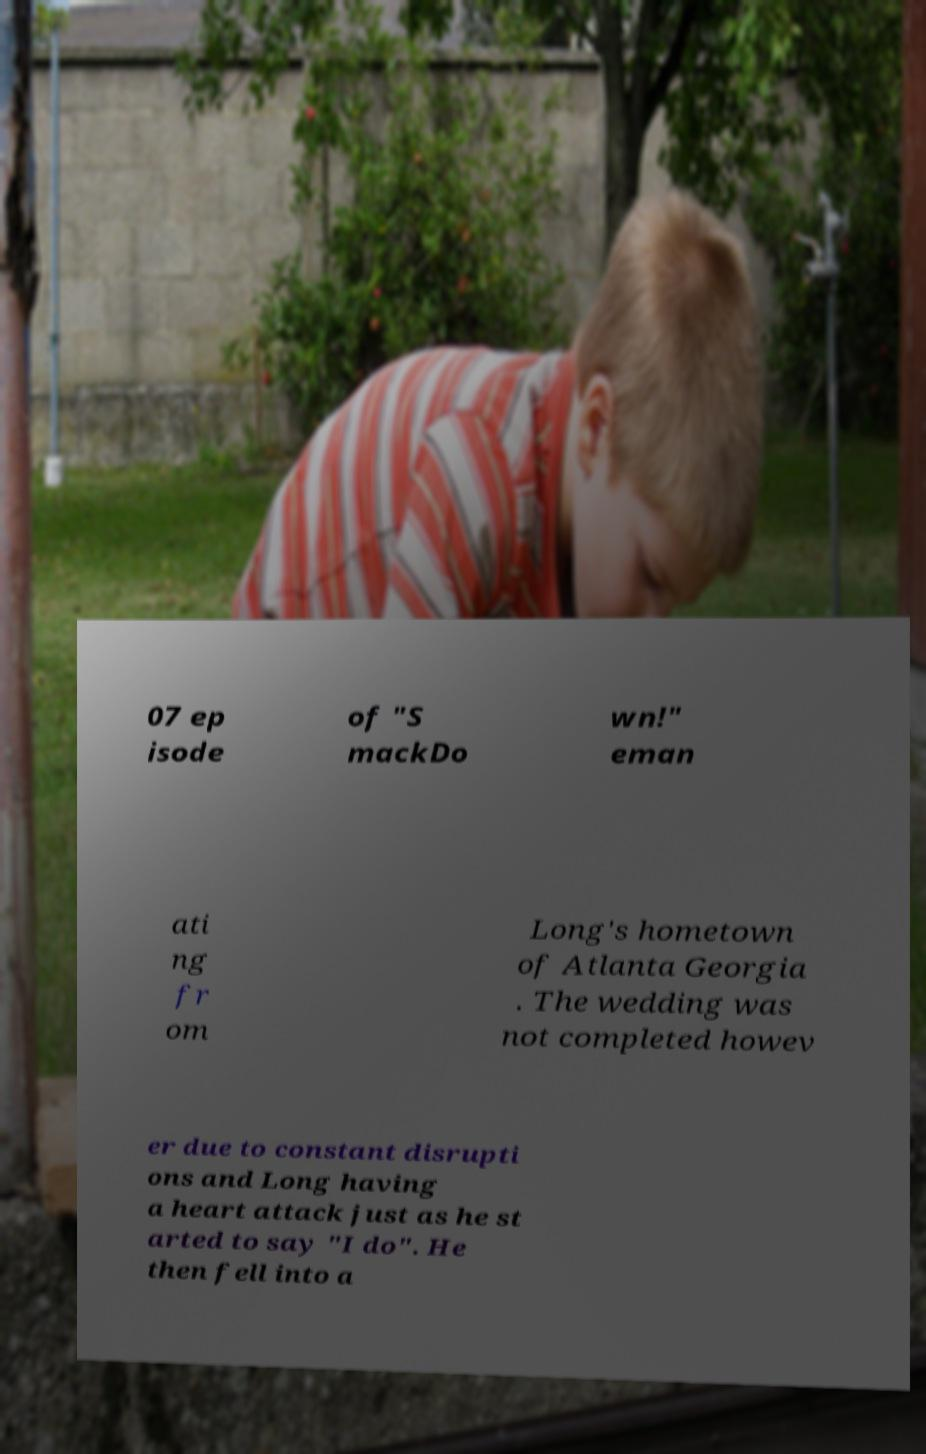Please identify and transcribe the text found in this image. 07 ep isode of "S mackDo wn!" eman ati ng fr om Long's hometown of Atlanta Georgia . The wedding was not completed howev er due to constant disrupti ons and Long having a heart attack just as he st arted to say "I do". He then fell into a 